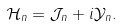Convert formula to latex. <formula><loc_0><loc_0><loc_500><loc_500>\mathcal { H } _ { n } = \mathcal { J } _ { n } + i \mathcal { Y } _ { n } .</formula> 